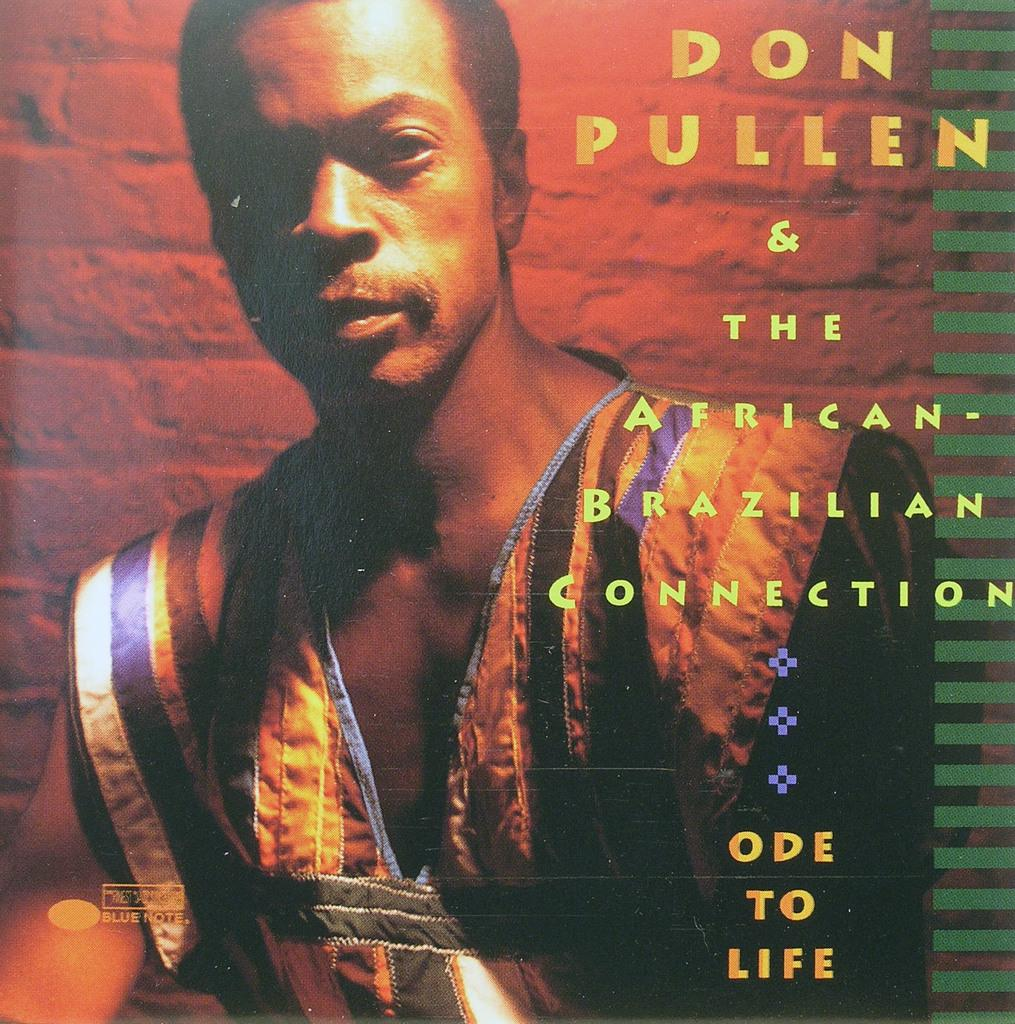<image>
Present a compact description of the photo's key features. a picture that says 'don pullen & the african-brazilian connection' on it 